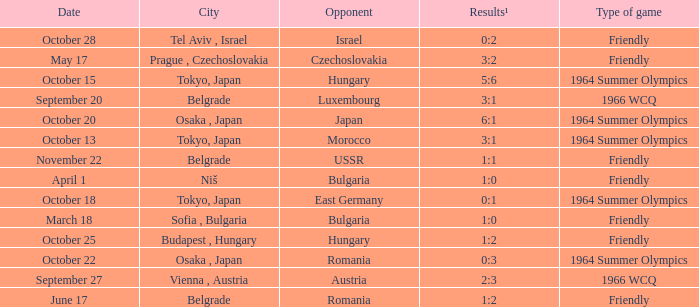Can you parse all the data within this table? {'header': ['Date', 'City', 'Opponent', 'Results¹', 'Type of game'], 'rows': [['October 28', 'Tel Aviv , Israel', 'Israel', '0:2', 'Friendly'], ['May 17', 'Prague , Czechoslovakia', 'Czechoslovakia', '3:2', 'Friendly'], ['October 15', 'Tokyo, Japan', 'Hungary', '5:6', '1964 Summer Olympics'], ['September 20', 'Belgrade', 'Luxembourg', '3:1', '1966 WCQ'], ['October 20', 'Osaka , Japan', 'Japan', '6:1', '1964 Summer Olympics'], ['October 13', 'Tokyo, Japan', 'Morocco', '3:1', '1964 Summer Olympics'], ['November 22', 'Belgrade', 'USSR', '1:1', 'Friendly'], ['April 1', 'Niš', 'Bulgaria', '1:0', 'Friendly'], ['October 18', 'Tokyo, Japan', 'East Germany', '0:1', '1964 Summer Olympics'], ['March 18', 'Sofia , Bulgaria', 'Bulgaria', '1:0', 'Friendly'], ['October 25', 'Budapest , Hungary', 'Hungary', '1:2', 'Friendly'], ['October 22', 'Osaka , Japan', 'Romania', '0:3', '1964 Summer Olympics'], ['September 27', 'Vienna , Austria', 'Austria', '2:3', '1966 WCQ'], ['June 17', 'Belgrade', 'Romania', '1:2', 'Friendly']]} What was the opponent on october 28? Israel. 